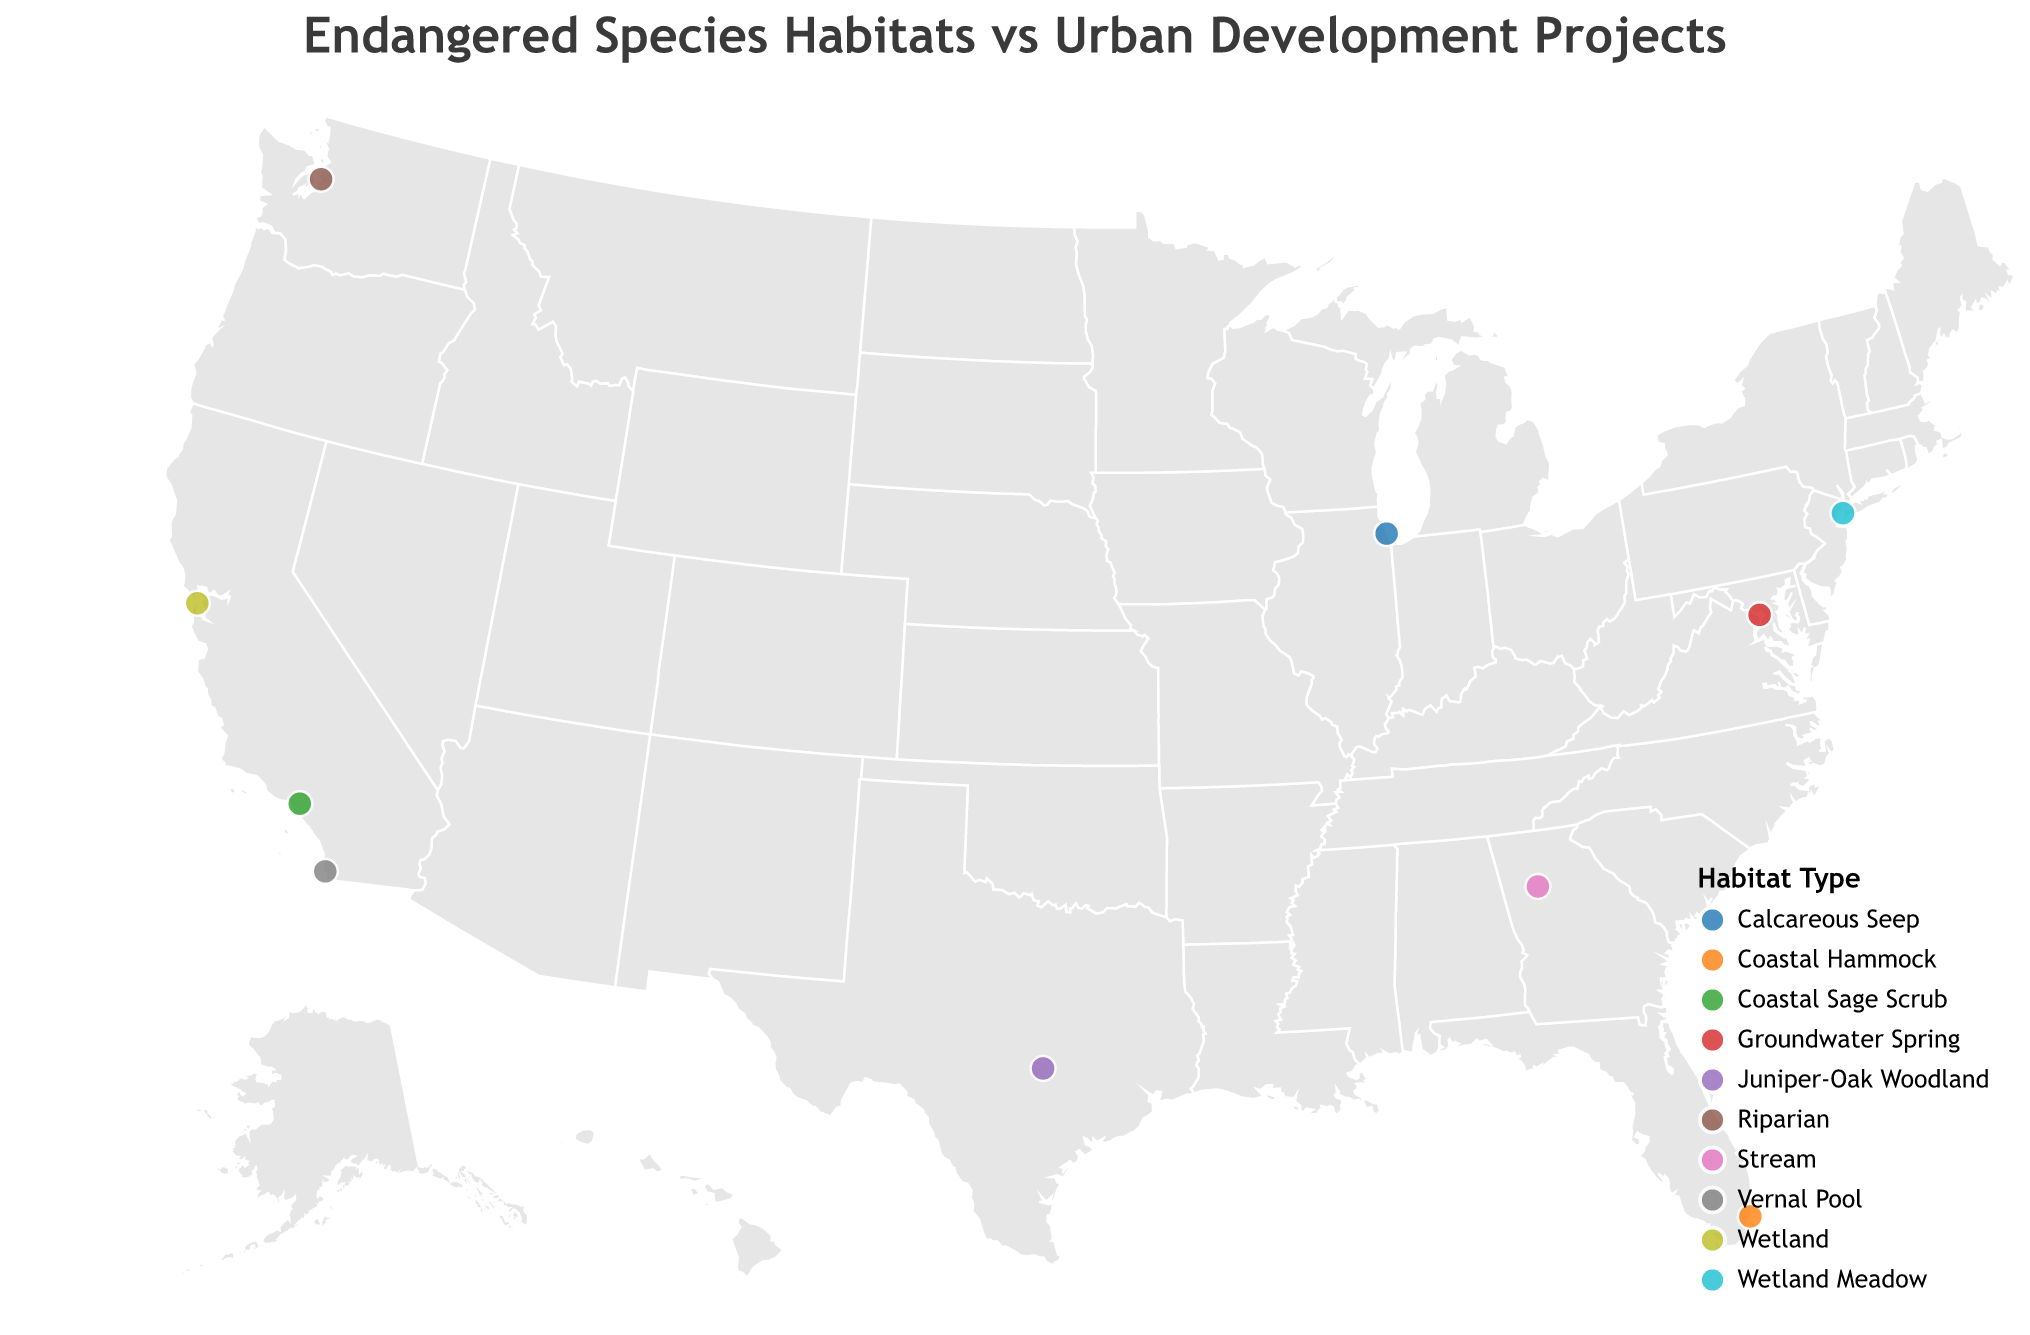What's the title of the plot? The title is usually located at the top of a plot and provides a brief description of what the plot represents. In this case, "Endangered Species Habitats vs Urban Development Projects" is clearly displayed.
Answer: Endangered Species Habitats vs Urban Development Projects How many endangered species are represented in the plot? To determine the number of endangered species, count the distinct data points on the map, each of which represents an endangered species. There are 10 circles.
Answer: 10 What habitat type is associated with the California Red-legged Frog? Hovering over or locating the California Red-legged Frog on the map reveals detailed information including its habitat type, which is indicated as a tooltip.
Answer: Wetland Which urban development project is closest to the San Francisco Downtown High-Rise on the map? By visually inspecting the map and looking for the geographic proximity of other projects to the San Francisco location, you can identify that the Los Angeles Skyscraper Complex is the closest.
Answer: Los Angeles Skyscraper Complex Which project involves development in a Wetland Meadow habitat type? Identifying projects by habitat type involves searching for circles color-coded to represent Wetland Meadow and using tooltips to verify the corresponding urban project.
Answer: Manhattan Mixed-Use Tower Which species’ habitat is located furthest south on the map? Analyzing the latitude values or visually inspecting the plots, the southernmost latitude corresponds to the Miami Blue Butterfly’s habitat.
Answer: Miami Blue Butterfly What is the most common habitat type represented on the plot? Count the number of circles corresponding to each habitat type by using the color legend and tooltips for assistance. Wetland has the highest frequency, with two circles (California Red-legged Frog and New York Fringed Orchid).
Answer: Wetland How many distinct habitat types are shown in the plot? The legend at the bottom right shows different habitat types. Counting the distinct entries results in 9 unique habitat types.
Answer: 9 Which urban project is associated with the Coastal Sage Scrub habitat? Using tooltips or hovering over each coastal sage scrub circle, the urban project can be identified.
Answer: Los Angeles Skyscraper Complex Is the New York Fringed Orchid habitat closer to the Washington D.C. Government Complex or the Manhattan Mixed-Use Tower? Based on geographic proximity on the map, locating both urban projects and comparing distances to the New York Fringed Orchid habitat indicates that it is closer to the Manhattan Mixed-Use Tower.
Answer: Manhattan Mixed-Use Tower 